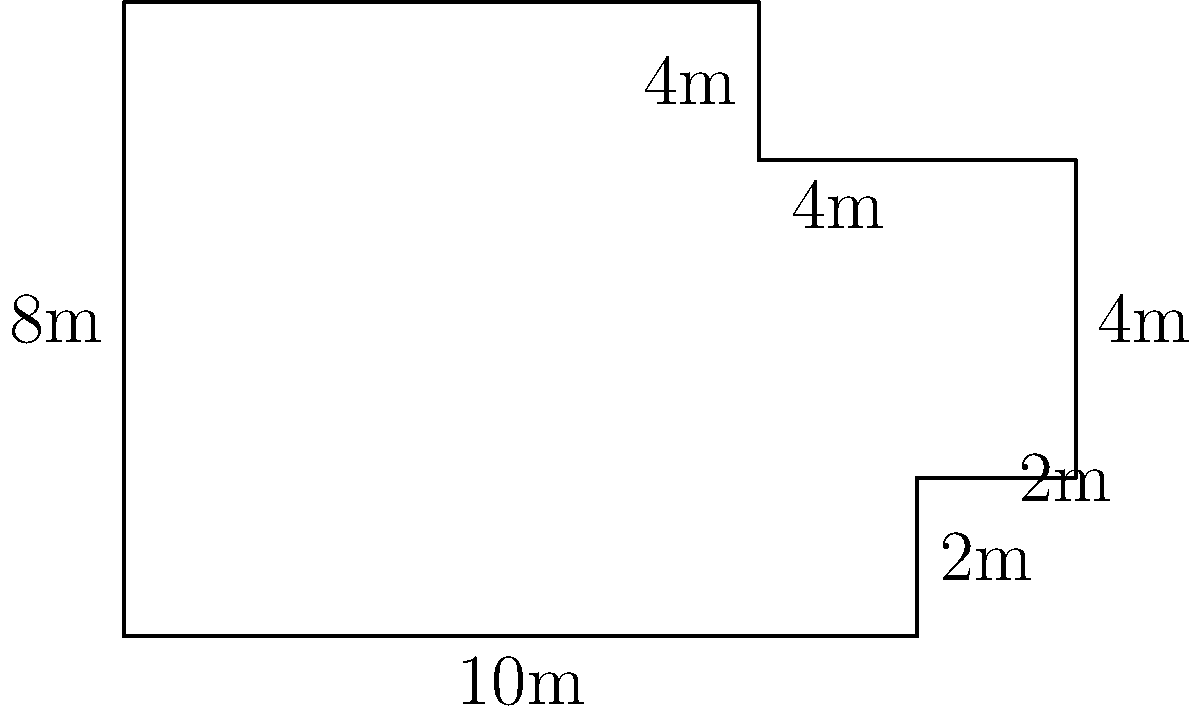In a landmark case, the judge presided over a trial in an unusually shaped courtroom. The floor plan of the courtroom is shown above, with measurements in meters. What is the total area of the courtroom floor in square meters? Let's break this down step-by-step:

1) We can divide the courtroom into three rectangles:
   - Rectangle A: 10m x 8m
   - Rectangle B: 2m x 4m
   - Rectangle C: 4m x 2m

2) Calculate the area of each rectangle:
   - Area of Rectangle A: $A_A = 10m \times 8m = 80m^2$
   - Area of Rectangle B: $A_B = 2m \times 4m = 8m^2$
   - Area of Rectangle C: $A_C = 4m \times 2m = 8m^2$

3) The total area is the sum of these three rectangles:
   $A_{total} = A_A + A_B + A_C$
   $A_{total} = 80m^2 + 8m^2 + 8m^2 = 96m^2$

Therefore, the total area of the courtroom floor is 96 square meters.
Answer: $96m^2$ 